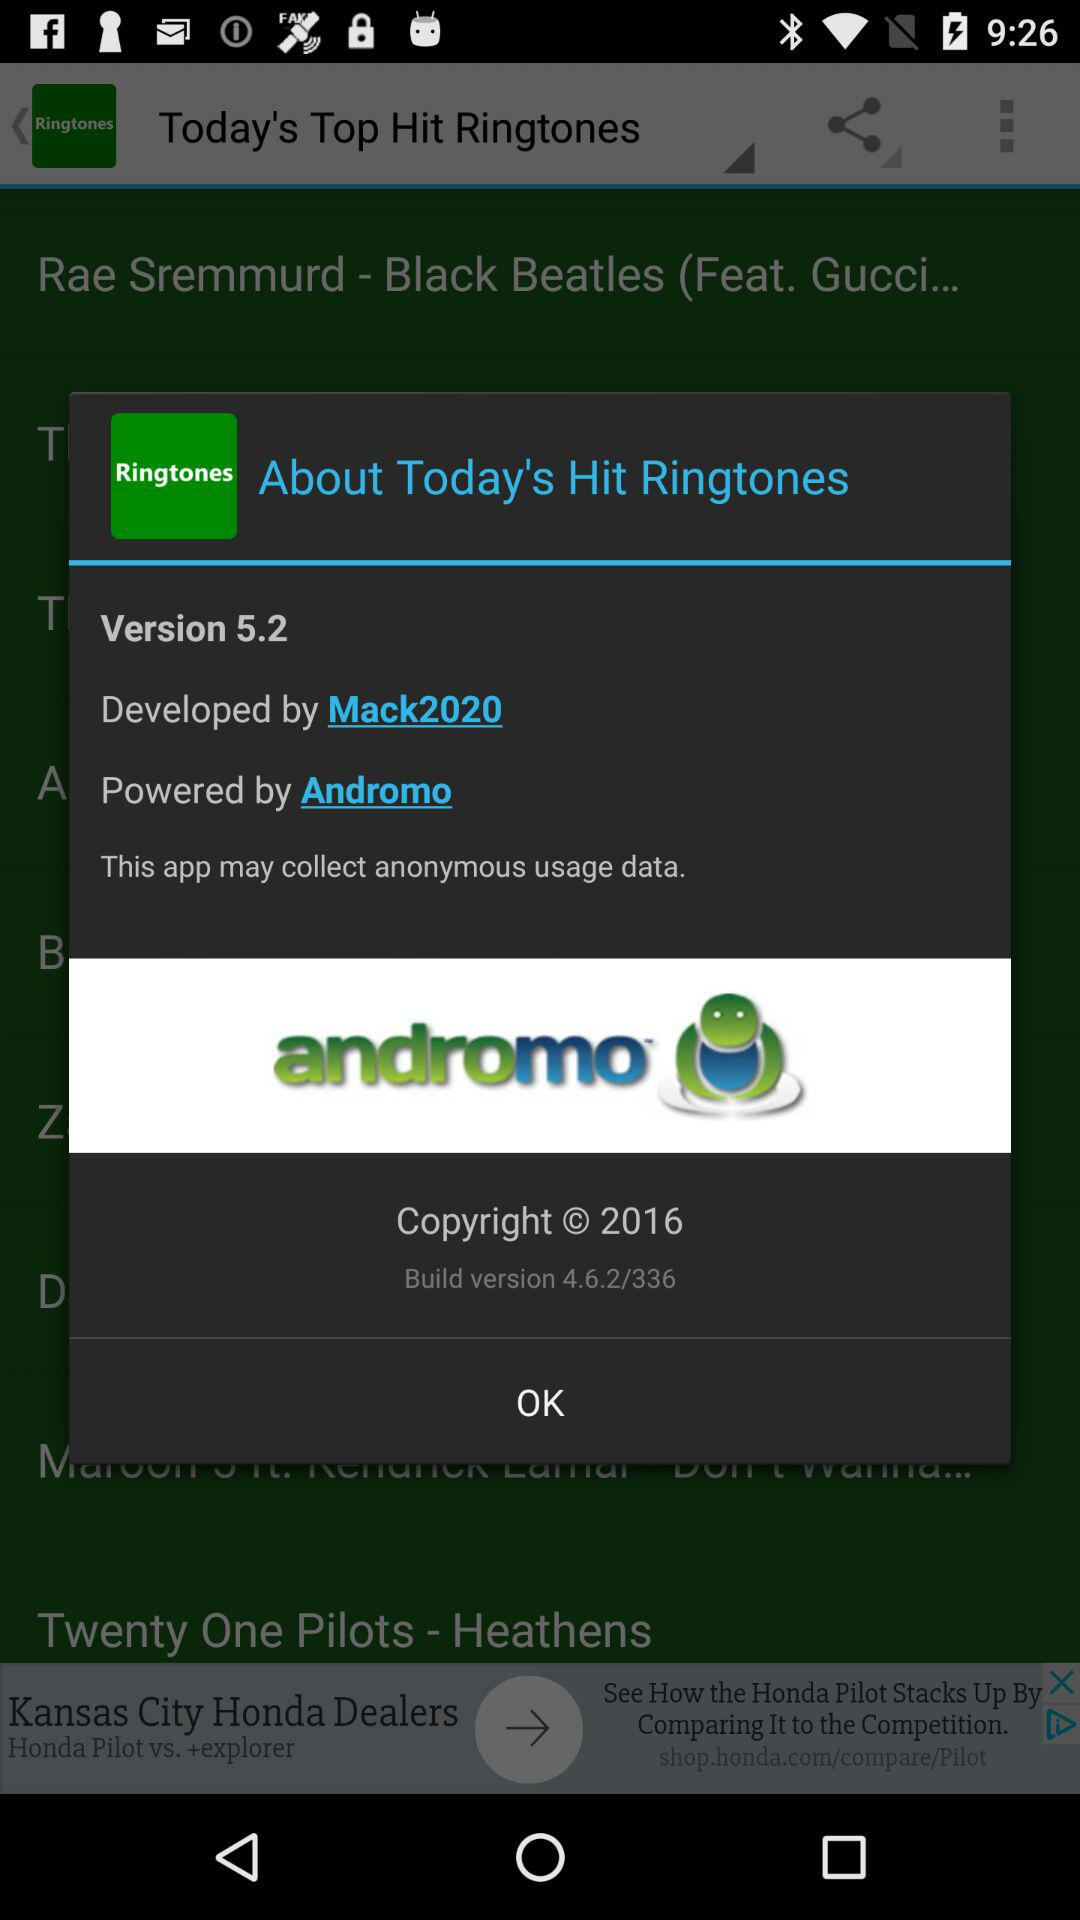By whom was the application developed? The application was developed by "Mack2020". 